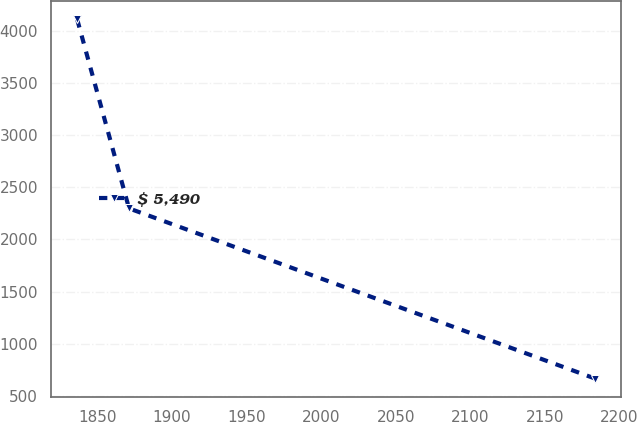Convert chart. <chart><loc_0><loc_0><loc_500><loc_500><line_chart><ecel><fcel>$ 5,490<nl><fcel>1836.54<fcel>4108.36<nl><fcel>1871.28<fcel>2297.76<nl><fcel>2183.91<fcel>665.92<nl></chart> 